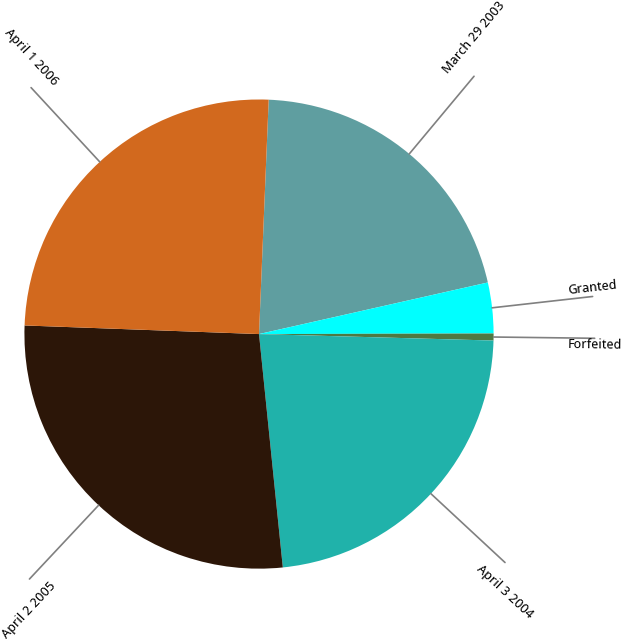<chart> <loc_0><loc_0><loc_500><loc_500><pie_chart><fcel>March 29 2003<fcel>Granted<fcel>Forfeited<fcel>April 3 2004<fcel>April 2 2005<fcel>April 1 2006<nl><fcel>20.81%<fcel>3.49%<fcel>0.48%<fcel>22.94%<fcel>27.2%<fcel>25.07%<nl></chart> 